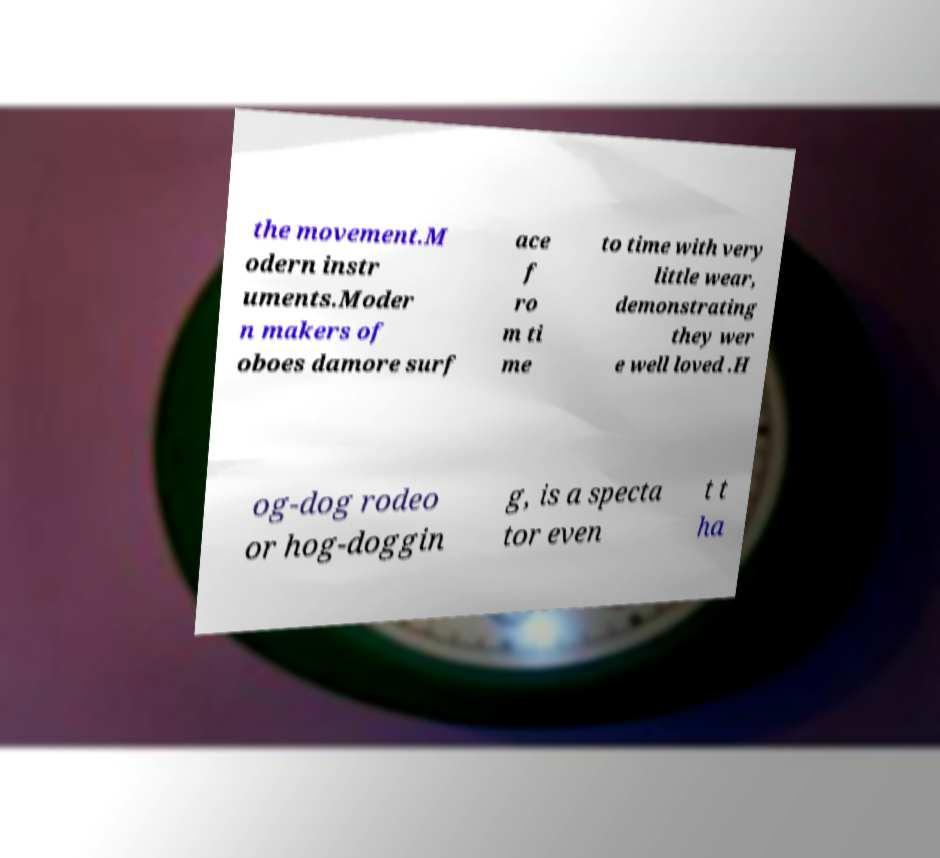For documentation purposes, I need the text within this image transcribed. Could you provide that? the movement.M odern instr uments.Moder n makers of oboes damore surf ace f ro m ti me to time with very little wear, demonstrating they wer e well loved .H og-dog rodeo or hog-doggin g, is a specta tor even t t ha 